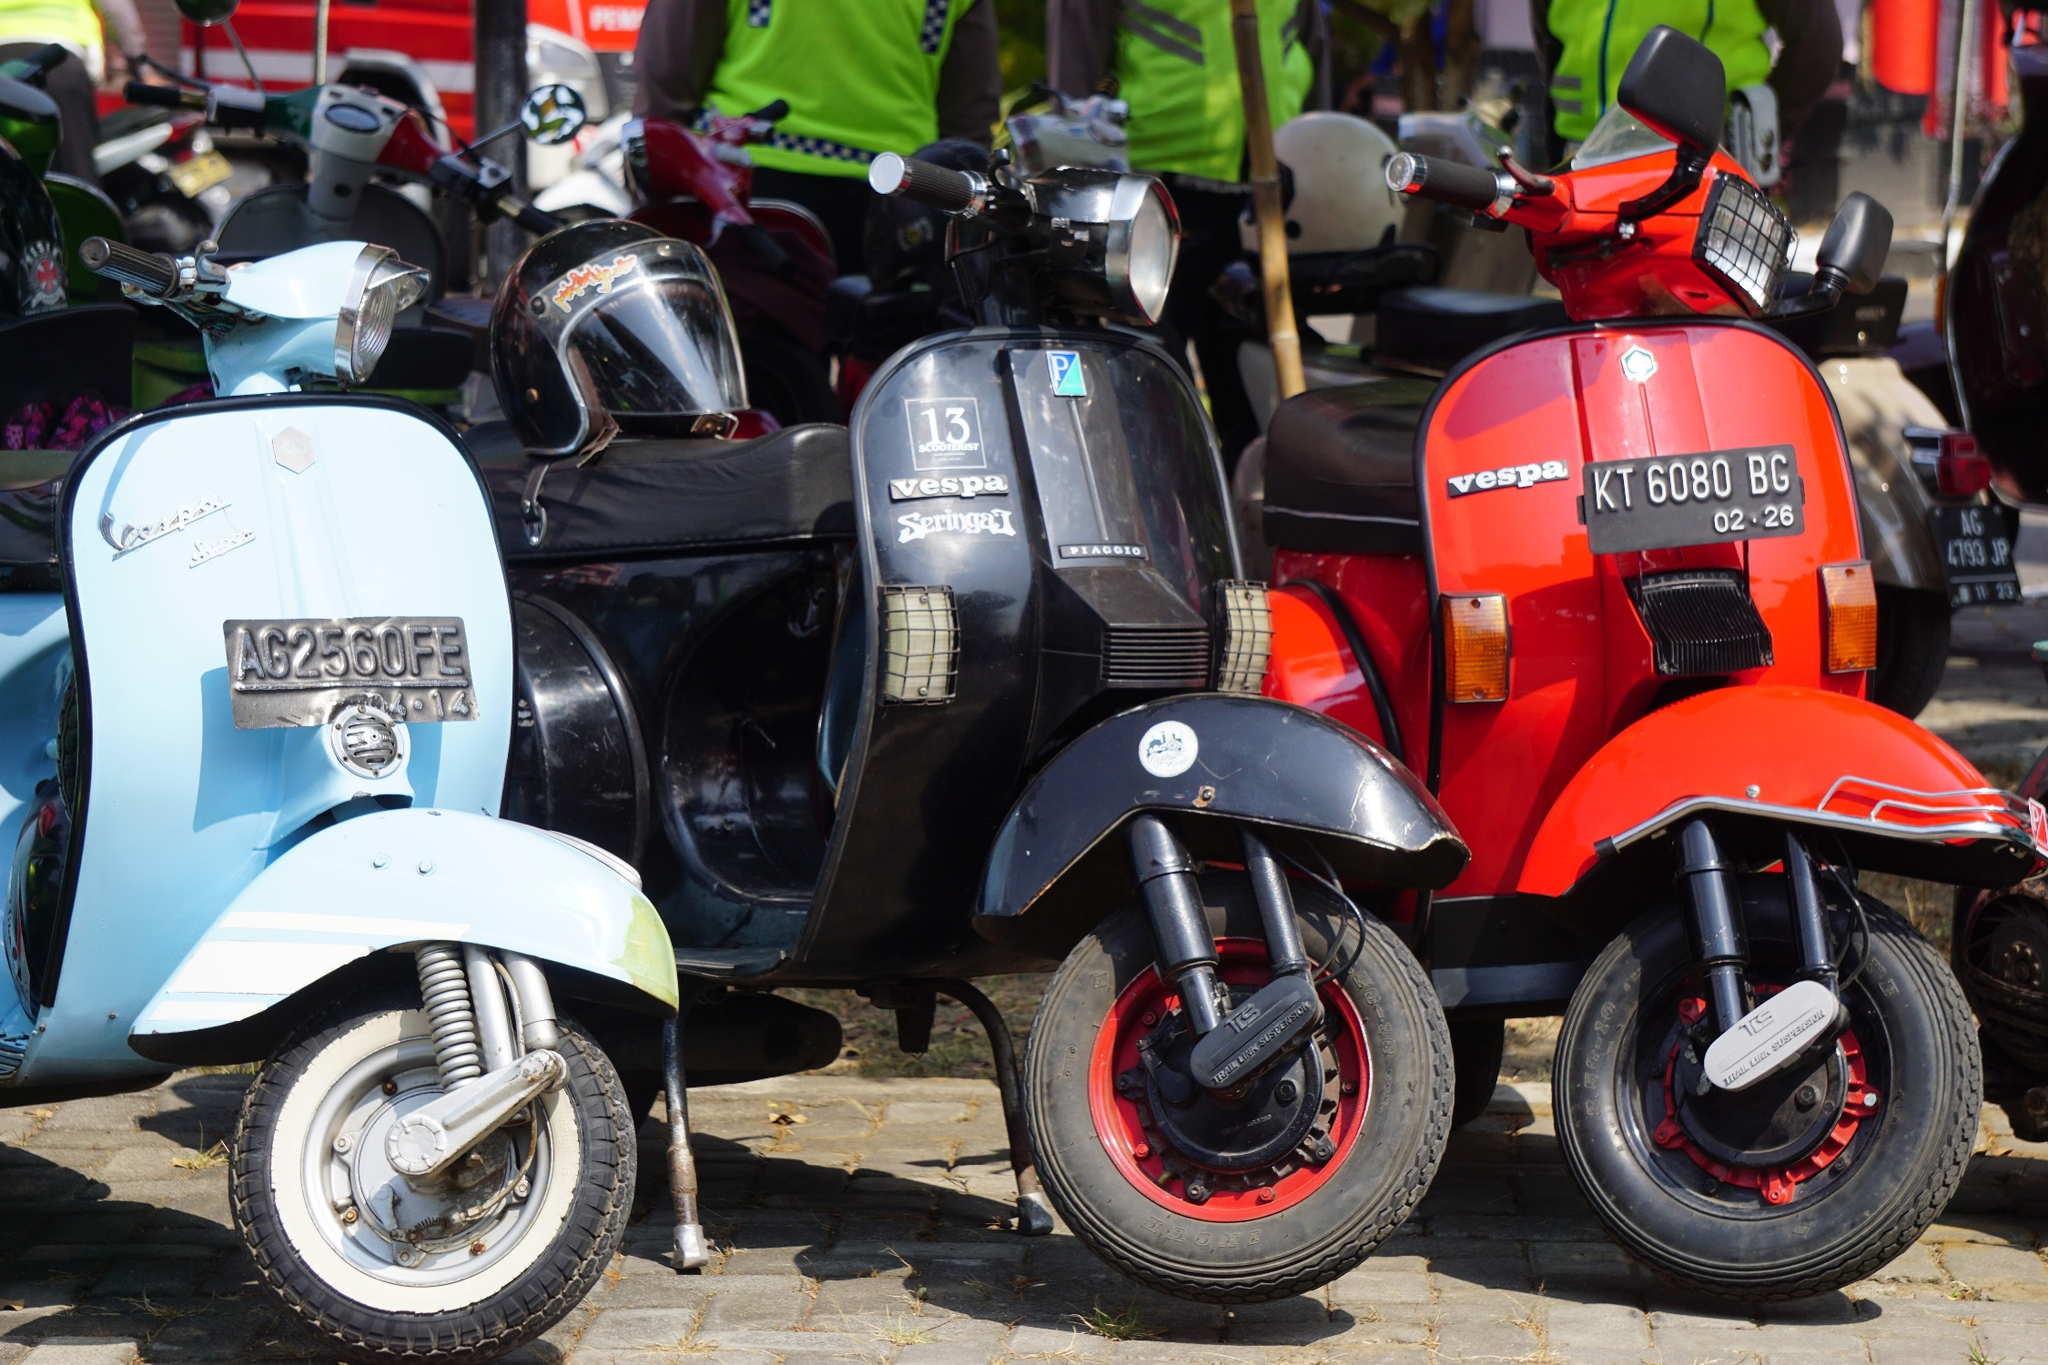Analyze the image in a comprehensive and detailed manner. This vibrant image brings to life a charming street scene featuring a group of Vespa scooters parked closely together on a cobblestone pathway. The scooters, each uniquely adorned and painted in bright colors like blue, black, and red, capture the viewer's attention. They are parked in a neat row, with details such as stickers and various license plates adding character to each vehicle. The perspective chosen focuses on the scooters, highlighting both their aesthetic appeal and functional design. In the background, flecks of a building with a red roof and additional scooters being attended to by people in bright green safety vests add depth to the composition. This image encapsulates a blend of nostalgic charm and modern-day hustle that is often characteristic of quaint European towns. The code 'sa_16257' mentioned adds no further identifiable information about a landmark or location. 